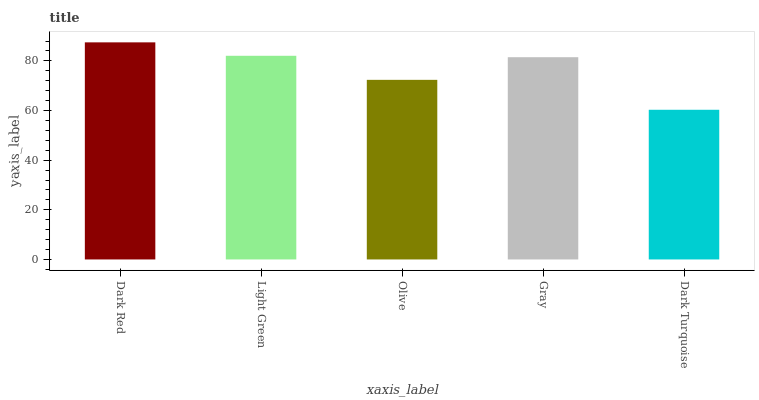Is Light Green the minimum?
Answer yes or no. No. Is Light Green the maximum?
Answer yes or no. No. Is Dark Red greater than Light Green?
Answer yes or no. Yes. Is Light Green less than Dark Red?
Answer yes or no. Yes. Is Light Green greater than Dark Red?
Answer yes or no. No. Is Dark Red less than Light Green?
Answer yes or no. No. Is Gray the high median?
Answer yes or no. Yes. Is Gray the low median?
Answer yes or no. Yes. Is Light Green the high median?
Answer yes or no. No. Is Dark Turquoise the low median?
Answer yes or no. No. 